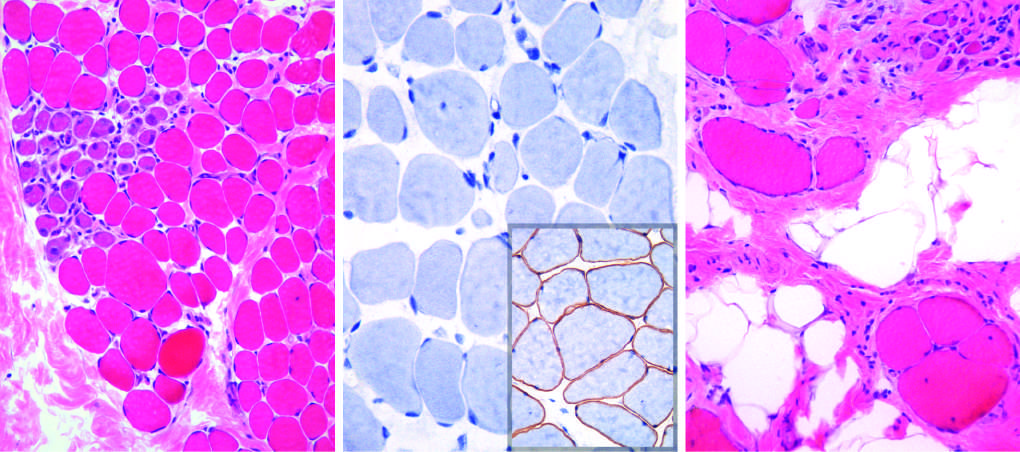what is seen as focal pink-staining connective tissue between myofibers?
Answer the question using a single word or phrase. Endomysial fibrosis 